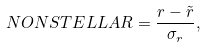<formula> <loc_0><loc_0><loc_500><loc_500>N O N S T E L L A R = \frac { r - \tilde { r } } { \sigma _ { r } } ,</formula> 